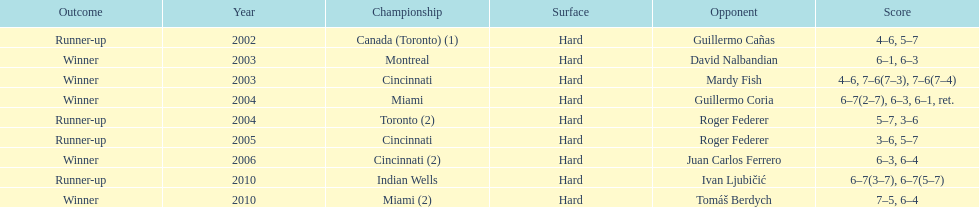How many championship competitions were held in toronto or montreal? 3. 